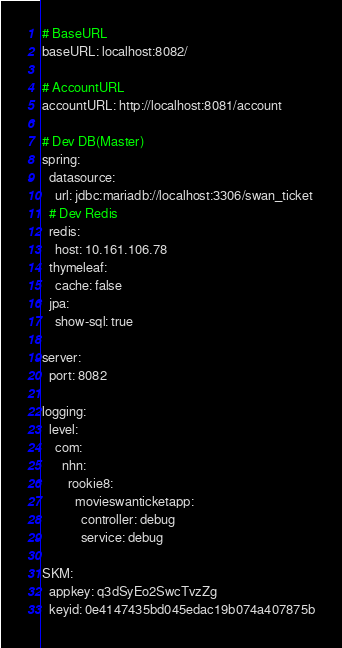<code> <loc_0><loc_0><loc_500><loc_500><_YAML_># BaseURL
baseURL: localhost:8082/

# AccountURL
accountURL: http://localhost:8081/account

# Dev DB(Master)
spring:
  datasource:
    url: jdbc:mariadb://localhost:3306/swan_ticket
  # Dev Redis
  redis:
    host: 10.161.106.78
  thymeleaf:
    cache: false
  jpa:
    show-sql: true

server:
  port: 8082

logging:
  level:
    com:
      nhn:
        rookie8:
          movieswanticketapp:
            controller: debug
            service: debug

SKM:
  appkey: q3dSyEo2SwcTvzZg
  keyid: 0e4147435bd045edac19b074a407875b</code> 